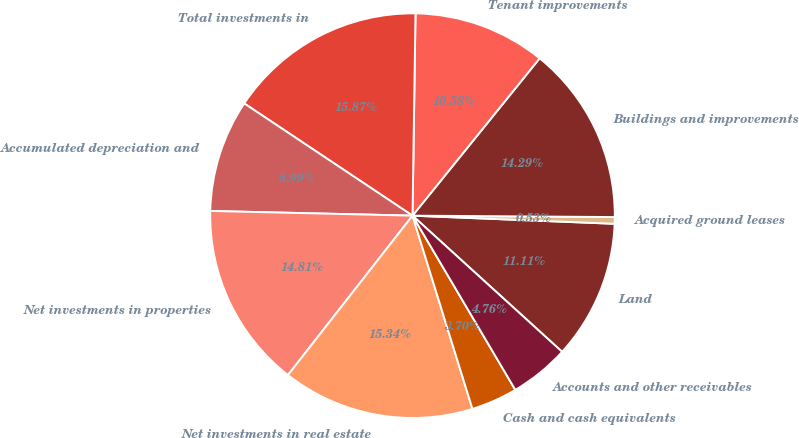Convert chart to OTSL. <chart><loc_0><loc_0><loc_500><loc_500><pie_chart><fcel>Land<fcel>Acquired ground leases<fcel>Buildings and improvements<fcel>Tenant improvements<fcel>Total investments in<fcel>Accumulated depreciation and<fcel>Net investments in properties<fcel>Net investments in real estate<fcel>Cash and cash equivalents<fcel>Accounts and other receivables<nl><fcel>11.11%<fcel>0.53%<fcel>14.29%<fcel>10.58%<fcel>15.87%<fcel>8.99%<fcel>14.81%<fcel>15.34%<fcel>3.7%<fcel>4.76%<nl></chart> 